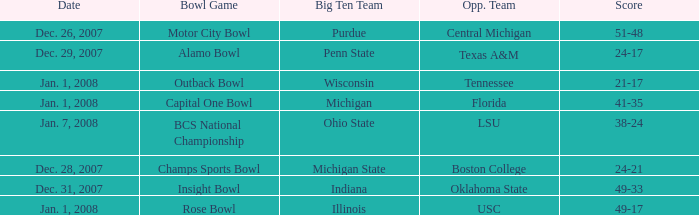What was the score of the BCS National Championship game? 38-24. 